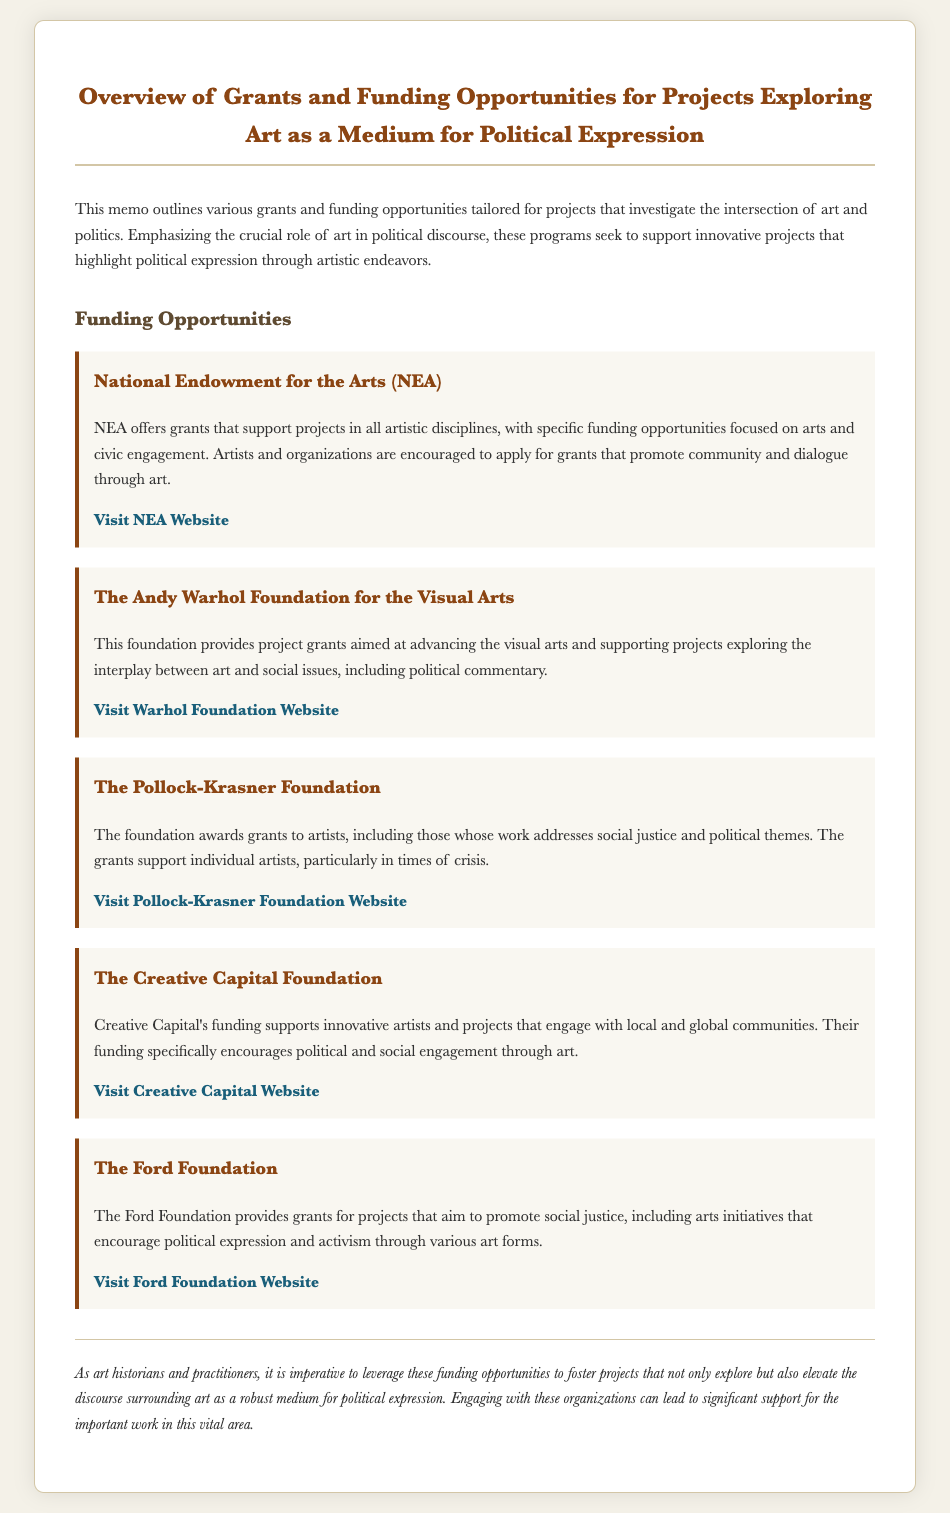What is the purpose of the memo? The memo outlines various grants and funding opportunities tailored for projects that investigate the intersection of art and politics.
Answer: Grants and funding opportunities What organization offers grants specifically for arts and civic engagement? The document mentions the NEA as an organization that offers grants supportive of arts and civic engagement.
Answer: National Endowment for the Arts (NEA) Which foundation provides project grants aimed at advancing the visual arts? According to the memo, The Andy Warhol Foundation for the Visual Arts provides project grants for this purpose.
Answer: The Andy Warhol Foundation for the Visual Arts What is the focus of The Pollock-Krasner Foundation grants? The grants provided by The Pollock-Krasner Foundation focus on supporting artists, particularly those addressing social justice and political themes.
Answer: Social justice and political themes Which foundation encourages political and social engagement through art? Creative Capital is noted in the memo for specifically encouraging political and social engagement through art.
Answer: The Creative Capital Foundation What type of projects does The Ford Foundation support? The Ford Foundation supports projects that aim to promote social justice, including arts initiatives.
Answer: Projects promoting social justice How many funding opportunities are listed in the memo? The memo lists five distinct funding opportunities for projects exploring art as a medium for political expression.
Answer: Five What is a key role of art highlighted in the document? The memo emphasizes the crucial role of art in political discourse.
Answer: Political discourse 